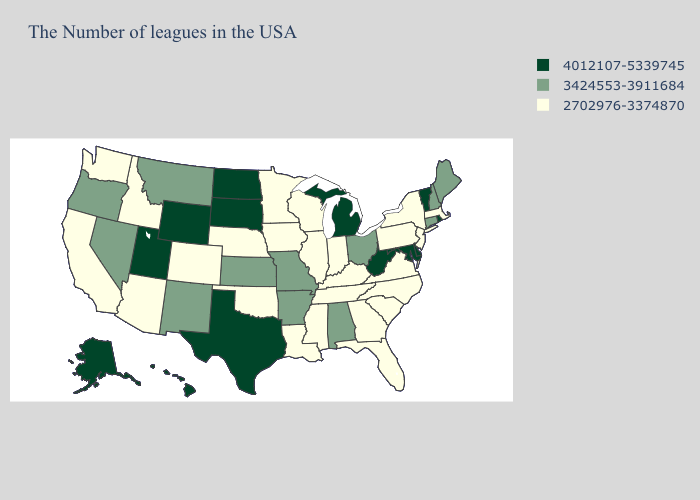What is the value of Louisiana?
Concise answer only. 2702976-3374870. What is the highest value in the USA?
Quick response, please. 4012107-5339745. What is the lowest value in the West?
Give a very brief answer. 2702976-3374870. What is the lowest value in the MidWest?
Concise answer only. 2702976-3374870. How many symbols are there in the legend?
Short answer required. 3. How many symbols are there in the legend?
Short answer required. 3. Name the states that have a value in the range 3424553-3911684?
Give a very brief answer. Maine, New Hampshire, Connecticut, Ohio, Alabama, Missouri, Arkansas, Kansas, New Mexico, Montana, Nevada, Oregon. Name the states that have a value in the range 3424553-3911684?
Answer briefly. Maine, New Hampshire, Connecticut, Ohio, Alabama, Missouri, Arkansas, Kansas, New Mexico, Montana, Nevada, Oregon. Does the map have missing data?
Give a very brief answer. No. What is the highest value in the USA?
Keep it brief. 4012107-5339745. Does Delaware have a higher value than California?
Short answer required. Yes. What is the value of Vermont?
Quick response, please. 4012107-5339745. What is the value of Idaho?
Quick response, please. 2702976-3374870. Name the states that have a value in the range 3424553-3911684?
Keep it brief. Maine, New Hampshire, Connecticut, Ohio, Alabama, Missouri, Arkansas, Kansas, New Mexico, Montana, Nevada, Oregon. Name the states that have a value in the range 3424553-3911684?
Keep it brief. Maine, New Hampshire, Connecticut, Ohio, Alabama, Missouri, Arkansas, Kansas, New Mexico, Montana, Nevada, Oregon. 